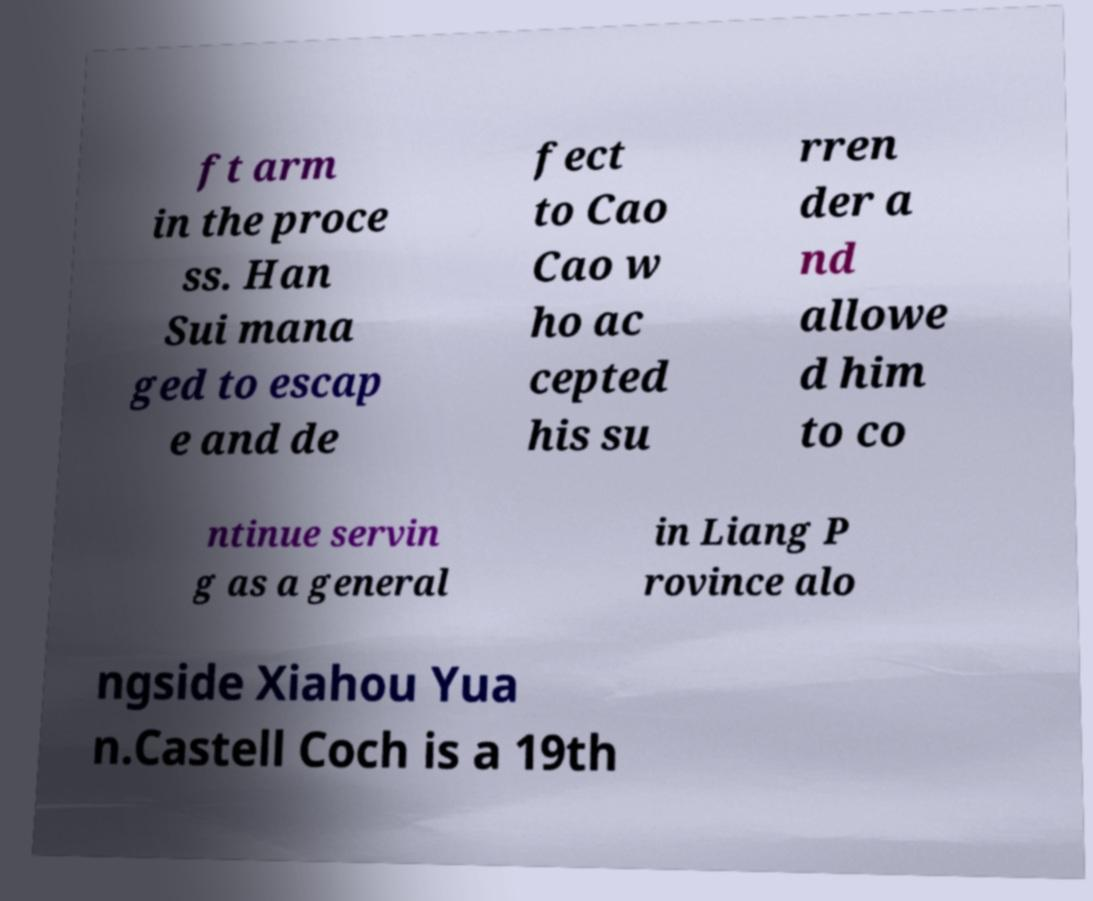Please read and relay the text visible in this image. What does it say? ft arm in the proce ss. Han Sui mana ged to escap e and de fect to Cao Cao w ho ac cepted his su rren der a nd allowe d him to co ntinue servin g as a general in Liang P rovince alo ngside Xiahou Yua n.Castell Coch is a 19th 